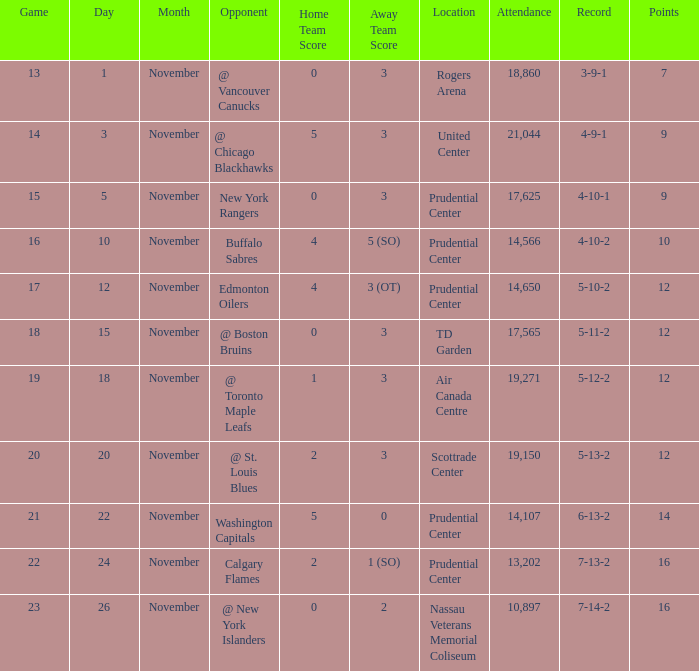What is the maximum number of points? 16.0. Would you be able to parse every entry in this table? {'header': ['Game', 'Day', 'Month', 'Opponent', 'Home Team Score', 'Away Team Score', 'Location', 'Attendance', 'Record', 'Points'], 'rows': [['13', '1', 'November', '@ Vancouver Canucks', '0', '3', 'Rogers Arena', '18,860', '3-9-1', '7'], ['14', '3', 'November', '@ Chicago Blackhawks', '5', '3', 'United Center', '21,044', '4-9-1', '9'], ['15', '5', 'November', 'New York Rangers', '0', '3', 'Prudential Center', '17,625', '4-10-1', '9'], ['16', '10', 'November', 'Buffalo Sabres', '4', '5 (SO)', 'Prudential Center', '14,566', '4-10-2', '10'], ['17', '12', 'November', 'Edmonton Oilers', '4', '3 (OT)', 'Prudential Center', '14,650', '5-10-2', '12'], ['18', '15', 'November', '@ Boston Bruins', '0', '3', 'TD Garden', '17,565', '5-11-2', '12'], ['19', '18', 'November', '@ Toronto Maple Leafs', '1', '3', 'Air Canada Centre', '19,271', '5-12-2', '12'], ['20', '20', 'November', '@ St. Louis Blues', '2', '3', 'Scottrade Center', '19,150', '5-13-2', '12'], ['21', '22', 'November', 'Washington Capitals', '5', '0', 'Prudential Center', '14,107', '6-13-2', '14'], ['22', '24', 'November', 'Calgary Flames', '2', '1 (SO)', 'Prudential Center', '13,202', '7-13-2', '16'], ['23', '26', 'November', '@ New York Islanders', '0', '2', 'Nassau Veterans Memorial Coliseum', '10,897', '7-14-2', '16']]} 